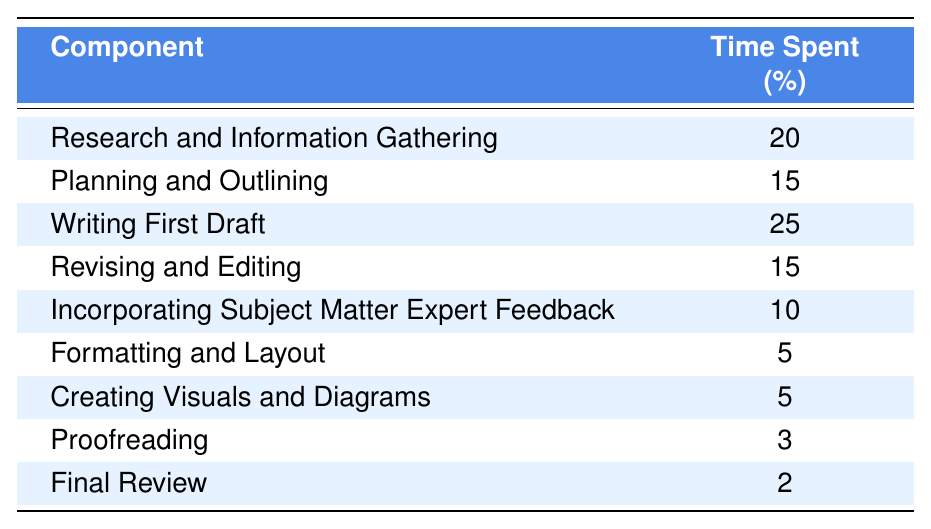What is the component that takes the most time in a technical writing project? By reviewing the table, we observe that "Writing First Draft" has the highest percentage of time spent at 25%.
Answer: Writing First Draft What percentage of time is spent on proofreading? The table shows that "Proofreading" takes 3% of the total time spent on the project.
Answer: 3% How much more time is allocated to research than formatting and layout? The table indicates that "Research and Information Gathering" is allocated 20% while "Formatting and Layout" takes 5%. Thus, the difference is 20% - 5% = 15%.
Answer: 15% What is the total percentage of time spent on the drafting and editing stages? The drafting and editing stages include "Writing First Draft" (25%), "Revising and Editing" (15%), and "Incorporating Subject Matter Expert Feedback" (10%), summing these gives 25% + 15% + 10% = 50%.
Answer: 50% Is the time spent on formatting and layout higher than the time spent on creating visuals and diagrams? According to the table, "Formatting and Layout" takes 5% while "Creating Visuals and Diagrams" also takes 5%. Therefore, the time spent on both is equal, resulting in a "No" answer.
Answer: No If you combine the time spent on planning and outlining with the time spent on revising and editing, what is the total percentage? The time spent on "Planning and Outlining" is 15% and "Revising and Editing" is 15%. Adding these together gives 15% + 15% = 30%.
Answer: 30% What is the combined time spent on components that involve visual aspects (creating visuals and formatting)? The time spent on "Formatting and Layout" is 5% and on "Creating Visuals and Diagrams" is also 5%. Therefore, 5% + 5% = 10% is spent on visual aspects.
Answer: 10% Does the time spent on final review constitute 10% or less of the total time? The table indicates that "Final Review" takes 2%, which is indeed 10% or less. Therefore, the answer is "Yes."
Answer: Yes What is the average time spent on all components of the project? To find the average, add all the percentages (20 + 15 + 25 + 15 + 10 + 5 + 5 + 3 + 2 = 100%), and divide by the number of components (9). The average is 100% / 9 = 11.11%.
Answer: 11.11% 